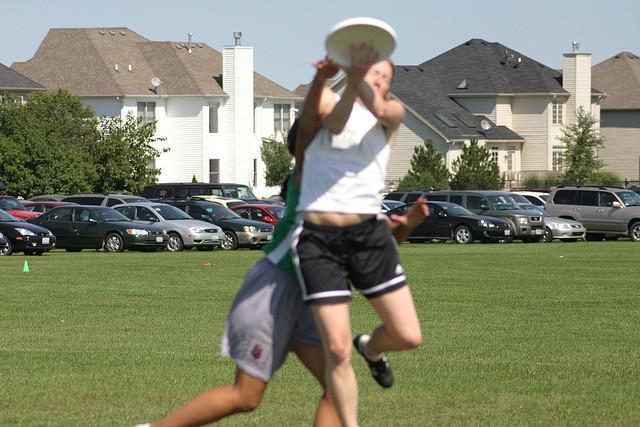How many cars are visible?
Give a very brief answer. 6. How many people can be seen?
Give a very brief answer. 2. 